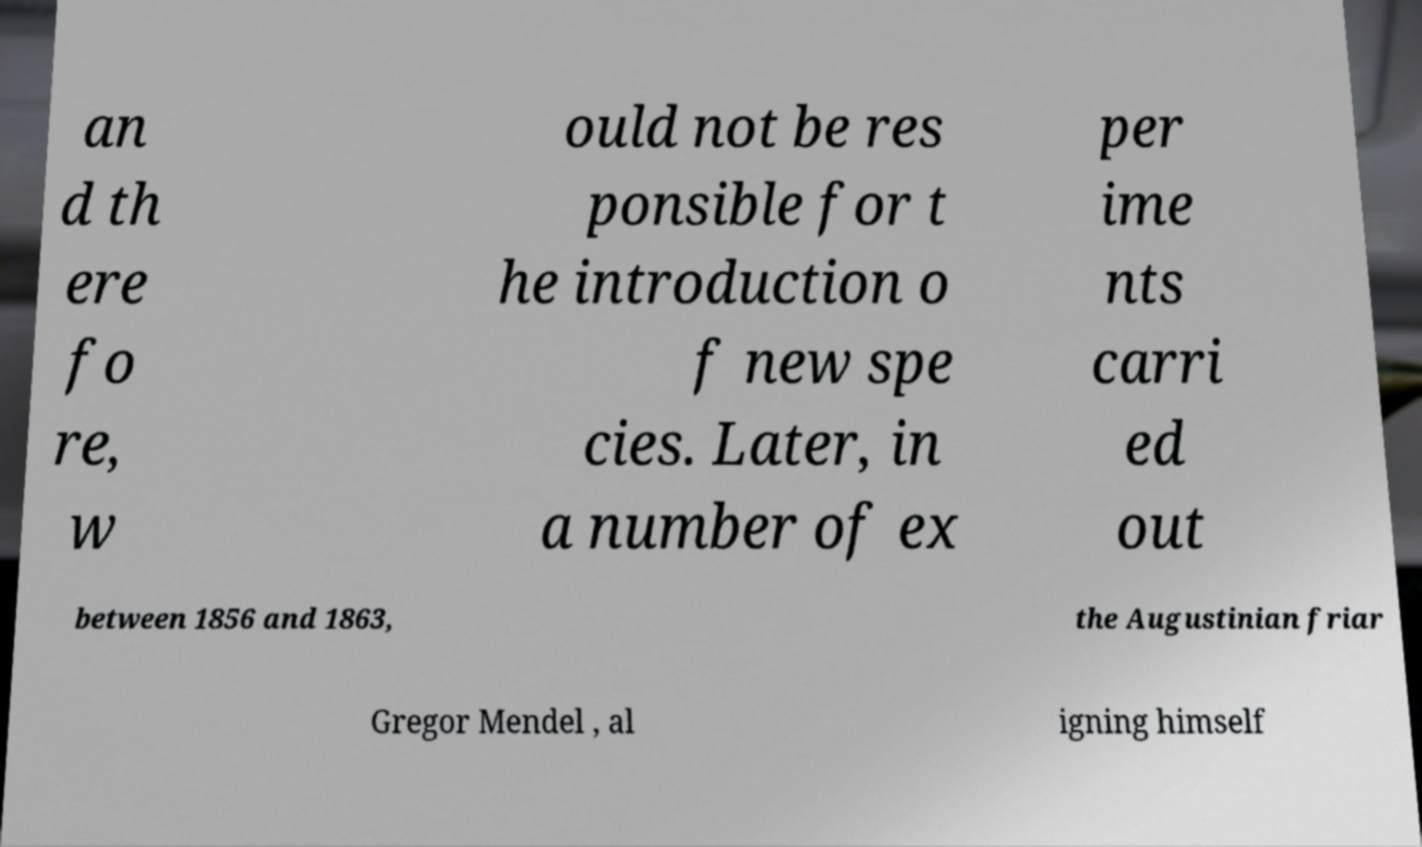Can you read and provide the text displayed in the image?This photo seems to have some interesting text. Can you extract and type it out for me? an d th ere fo re, w ould not be res ponsible for t he introduction o f new spe cies. Later, in a number of ex per ime nts carri ed out between 1856 and 1863, the Augustinian friar Gregor Mendel , al igning himself 